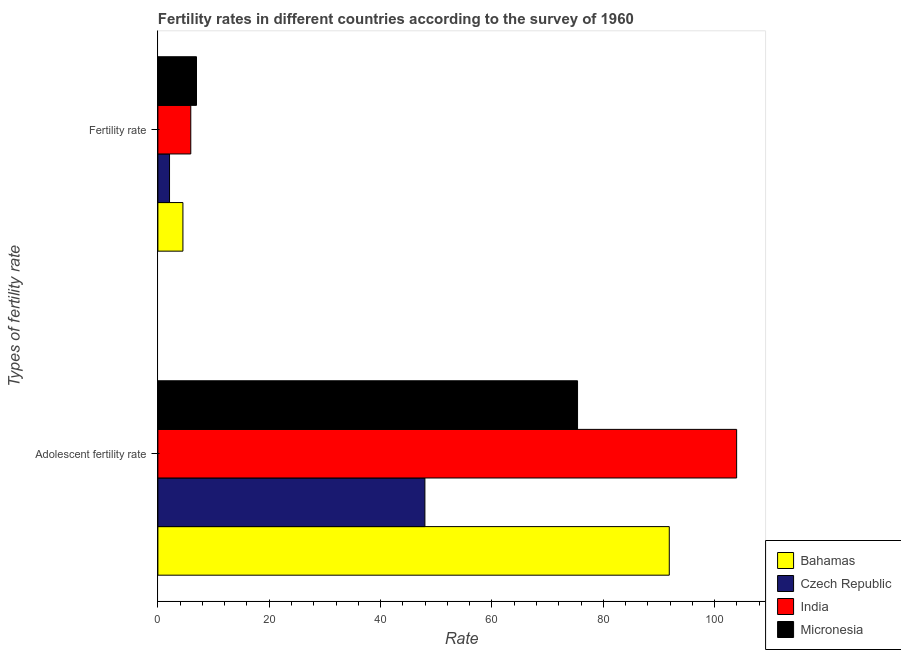How many groups of bars are there?
Provide a short and direct response. 2. Are the number of bars per tick equal to the number of legend labels?
Make the answer very short. Yes. How many bars are there on the 1st tick from the top?
Ensure brevity in your answer.  4. What is the label of the 1st group of bars from the top?
Offer a terse response. Fertility rate. What is the fertility rate in Bahamas?
Provide a succinct answer. 4.5. Across all countries, what is the maximum fertility rate?
Ensure brevity in your answer.  6.93. Across all countries, what is the minimum fertility rate?
Make the answer very short. 2.09. In which country was the fertility rate maximum?
Provide a succinct answer. Micronesia. In which country was the adolescent fertility rate minimum?
Offer a very short reply. Czech Republic. What is the total adolescent fertility rate in the graph?
Your response must be concise. 319.1. What is the difference between the adolescent fertility rate in Czech Republic and that in Micronesia?
Ensure brevity in your answer.  -27.41. What is the difference between the adolescent fertility rate in India and the fertility rate in Bahamas?
Make the answer very short. 99.44. What is the average adolescent fertility rate per country?
Make the answer very short. 79.78. What is the difference between the adolescent fertility rate and fertility rate in Czech Republic?
Give a very brief answer. 45.86. What is the ratio of the fertility rate in Micronesia to that in India?
Give a very brief answer. 1.17. What does the 1st bar from the top in Adolescent fertility rate represents?
Make the answer very short. Micronesia. What does the 1st bar from the bottom in Fertility rate represents?
Give a very brief answer. Bahamas. Are all the bars in the graph horizontal?
Your response must be concise. Yes. How many countries are there in the graph?
Ensure brevity in your answer.  4. Does the graph contain any zero values?
Offer a terse response. No. What is the title of the graph?
Make the answer very short. Fertility rates in different countries according to the survey of 1960. What is the label or title of the X-axis?
Keep it short and to the point. Rate. What is the label or title of the Y-axis?
Make the answer very short. Types of fertility rate. What is the Rate in Bahamas in Adolescent fertility rate?
Keep it short and to the point. 91.84. What is the Rate of Czech Republic in Adolescent fertility rate?
Make the answer very short. 47.95. What is the Rate in India in Adolescent fertility rate?
Offer a very short reply. 103.94. What is the Rate in Micronesia in Adolescent fertility rate?
Offer a very short reply. 75.37. What is the Rate of Bahamas in Fertility rate?
Give a very brief answer. 4.5. What is the Rate in Czech Republic in Fertility rate?
Give a very brief answer. 2.09. What is the Rate of India in Fertility rate?
Your response must be concise. 5.91. What is the Rate of Micronesia in Fertility rate?
Offer a terse response. 6.93. Across all Types of fertility rate, what is the maximum Rate of Bahamas?
Your answer should be compact. 91.84. Across all Types of fertility rate, what is the maximum Rate of Czech Republic?
Keep it short and to the point. 47.95. Across all Types of fertility rate, what is the maximum Rate of India?
Provide a succinct answer. 103.94. Across all Types of fertility rate, what is the maximum Rate in Micronesia?
Give a very brief answer. 75.37. Across all Types of fertility rate, what is the minimum Rate of Bahamas?
Your answer should be compact. 4.5. Across all Types of fertility rate, what is the minimum Rate of Czech Republic?
Provide a succinct answer. 2.09. Across all Types of fertility rate, what is the minimum Rate of India?
Offer a very short reply. 5.91. Across all Types of fertility rate, what is the minimum Rate of Micronesia?
Provide a succinct answer. 6.93. What is the total Rate in Bahamas in the graph?
Provide a succinct answer. 96.34. What is the total Rate of Czech Republic in the graph?
Offer a very short reply. 50.04. What is the total Rate of India in the graph?
Offer a very short reply. 109.84. What is the total Rate of Micronesia in the graph?
Your response must be concise. 82.3. What is the difference between the Rate in Bahamas in Adolescent fertility rate and that in Fertility rate?
Provide a short and direct response. 87.35. What is the difference between the Rate in Czech Republic in Adolescent fertility rate and that in Fertility rate?
Give a very brief answer. 45.86. What is the difference between the Rate of India in Adolescent fertility rate and that in Fertility rate?
Provide a succinct answer. 98.03. What is the difference between the Rate of Micronesia in Adolescent fertility rate and that in Fertility rate?
Keep it short and to the point. 68.43. What is the difference between the Rate in Bahamas in Adolescent fertility rate and the Rate in Czech Republic in Fertility rate?
Your answer should be very brief. 89.75. What is the difference between the Rate in Bahamas in Adolescent fertility rate and the Rate in India in Fertility rate?
Your answer should be compact. 85.94. What is the difference between the Rate in Bahamas in Adolescent fertility rate and the Rate in Micronesia in Fertility rate?
Keep it short and to the point. 84.91. What is the difference between the Rate of Czech Republic in Adolescent fertility rate and the Rate of India in Fertility rate?
Offer a terse response. 42.05. What is the difference between the Rate of Czech Republic in Adolescent fertility rate and the Rate of Micronesia in Fertility rate?
Provide a short and direct response. 41.02. What is the difference between the Rate in India in Adolescent fertility rate and the Rate in Micronesia in Fertility rate?
Keep it short and to the point. 97. What is the average Rate in Bahamas per Types of fertility rate?
Your response must be concise. 48.17. What is the average Rate of Czech Republic per Types of fertility rate?
Make the answer very short. 25.02. What is the average Rate of India per Types of fertility rate?
Your answer should be compact. 54.92. What is the average Rate in Micronesia per Types of fertility rate?
Give a very brief answer. 41.15. What is the difference between the Rate of Bahamas and Rate of Czech Republic in Adolescent fertility rate?
Keep it short and to the point. 43.89. What is the difference between the Rate of Bahamas and Rate of India in Adolescent fertility rate?
Offer a terse response. -12.1. What is the difference between the Rate of Bahamas and Rate of Micronesia in Adolescent fertility rate?
Give a very brief answer. 16.47. What is the difference between the Rate in Czech Republic and Rate in India in Adolescent fertility rate?
Your answer should be compact. -55.98. What is the difference between the Rate in Czech Republic and Rate in Micronesia in Adolescent fertility rate?
Ensure brevity in your answer.  -27.41. What is the difference between the Rate of India and Rate of Micronesia in Adolescent fertility rate?
Offer a terse response. 28.57. What is the difference between the Rate in Bahamas and Rate in Czech Republic in Fertility rate?
Make the answer very short. 2.4. What is the difference between the Rate of Bahamas and Rate of India in Fertility rate?
Provide a succinct answer. -1.41. What is the difference between the Rate of Bahamas and Rate of Micronesia in Fertility rate?
Offer a terse response. -2.44. What is the difference between the Rate of Czech Republic and Rate of India in Fertility rate?
Your answer should be very brief. -3.82. What is the difference between the Rate in Czech Republic and Rate in Micronesia in Fertility rate?
Make the answer very short. -4.84. What is the difference between the Rate of India and Rate of Micronesia in Fertility rate?
Give a very brief answer. -1.03. What is the ratio of the Rate in Bahamas in Adolescent fertility rate to that in Fertility rate?
Keep it short and to the point. 20.43. What is the ratio of the Rate of Czech Republic in Adolescent fertility rate to that in Fertility rate?
Offer a terse response. 22.94. What is the ratio of the Rate in India in Adolescent fertility rate to that in Fertility rate?
Offer a terse response. 17.6. What is the ratio of the Rate in Micronesia in Adolescent fertility rate to that in Fertility rate?
Offer a very short reply. 10.87. What is the difference between the highest and the second highest Rate in Bahamas?
Give a very brief answer. 87.35. What is the difference between the highest and the second highest Rate of Czech Republic?
Keep it short and to the point. 45.86. What is the difference between the highest and the second highest Rate in India?
Ensure brevity in your answer.  98.03. What is the difference between the highest and the second highest Rate of Micronesia?
Give a very brief answer. 68.43. What is the difference between the highest and the lowest Rate in Bahamas?
Provide a succinct answer. 87.35. What is the difference between the highest and the lowest Rate of Czech Republic?
Keep it short and to the point. 45.86. What is the difference between the highest and the lowest Rate of India?
Offer a terse response. 98.03. What is the difference between the highest and the lowest Rate of Micronesia?
Keep it short and to the point. 68.43. 